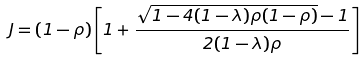Convert formula to latex. <formula><loc_0><loc_0><loc_500><loc_500>J = ( 1 - \rho ) \left [ 1 + \frac { \sqrt { 1 - 4 ( 1 - \lambda ) \rho ( 1 - \rho ) } - 1 } { 2 ( 1 - \lambda ) \rho } \right ]</formula> 